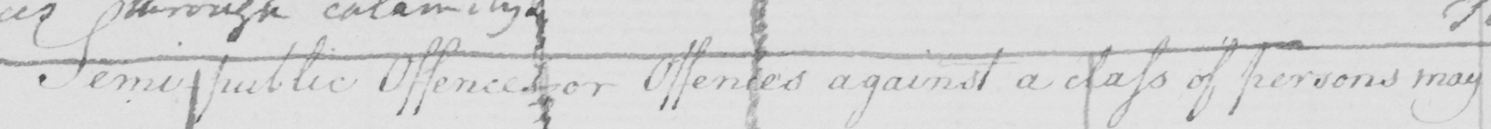What text is written in this handwritten line? Semi-public Offences , or Offences against a class of persons may 